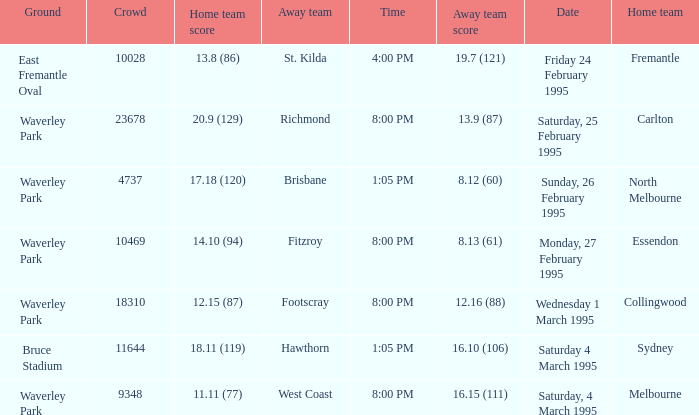Name the ground for essendon Waverley Park. 